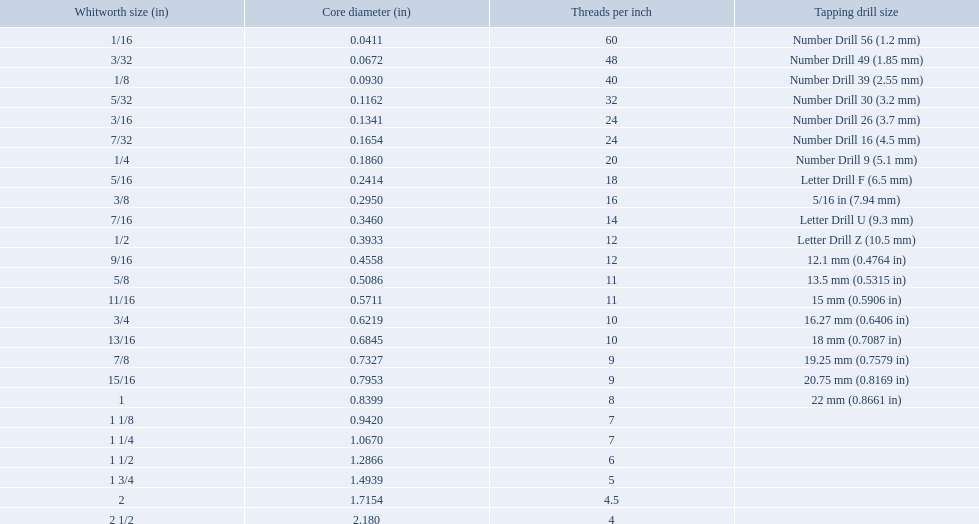What are the standard whitworth sizes in inches? 1/16, 3/32, 1/8, 5/32, 3/16, 7/32, 1/4, 5/16, 3/8, 7/16, 1/2, 9/16, 5/8, 11/16, 3/4, 13/16, 7/8, 15/16, 1, 1 1/8, 1 1/4, 1 1/2, 1 3/4, 2, 2 1/2. How many threads per inch does the 3/16 size have? 24. Which size (in inches) has the same number of threads? 7/32. 